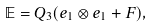Convert formula to latex. <formula><loc_0><loc_0><loc_500><loc_500>\mathbb { E } = Q _ { 3 } ( e _ { 1 } \otimes e _ { 1 } + F ) ,</formula> 